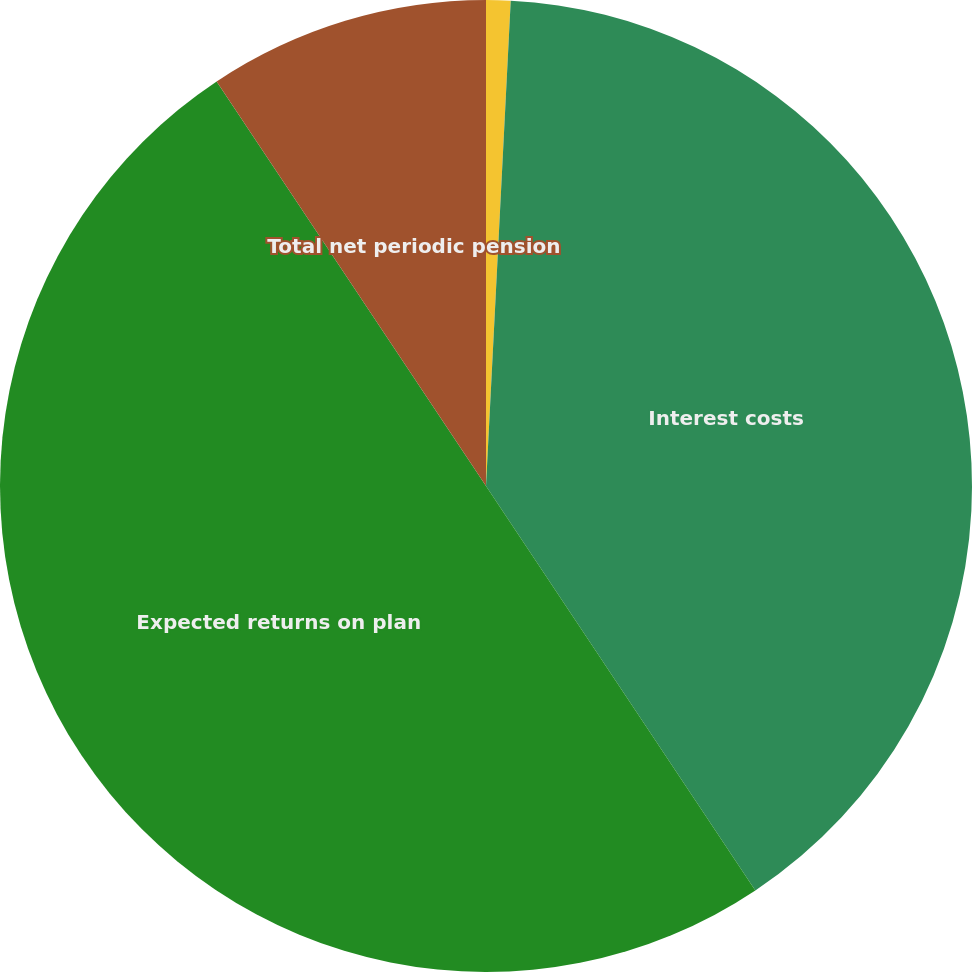Convert chart. <chart><loc_0><loc_0><loc_500><loc_500><pie_chart><fcel>Service costs<fcel>Interest costs<fcel>Expected returns on plan<fcel>Total net periodic pension<nl><fcel>0.81%<fcel>39.84%<fcel>50.0%<fcel>9.35%<nl></chart> 